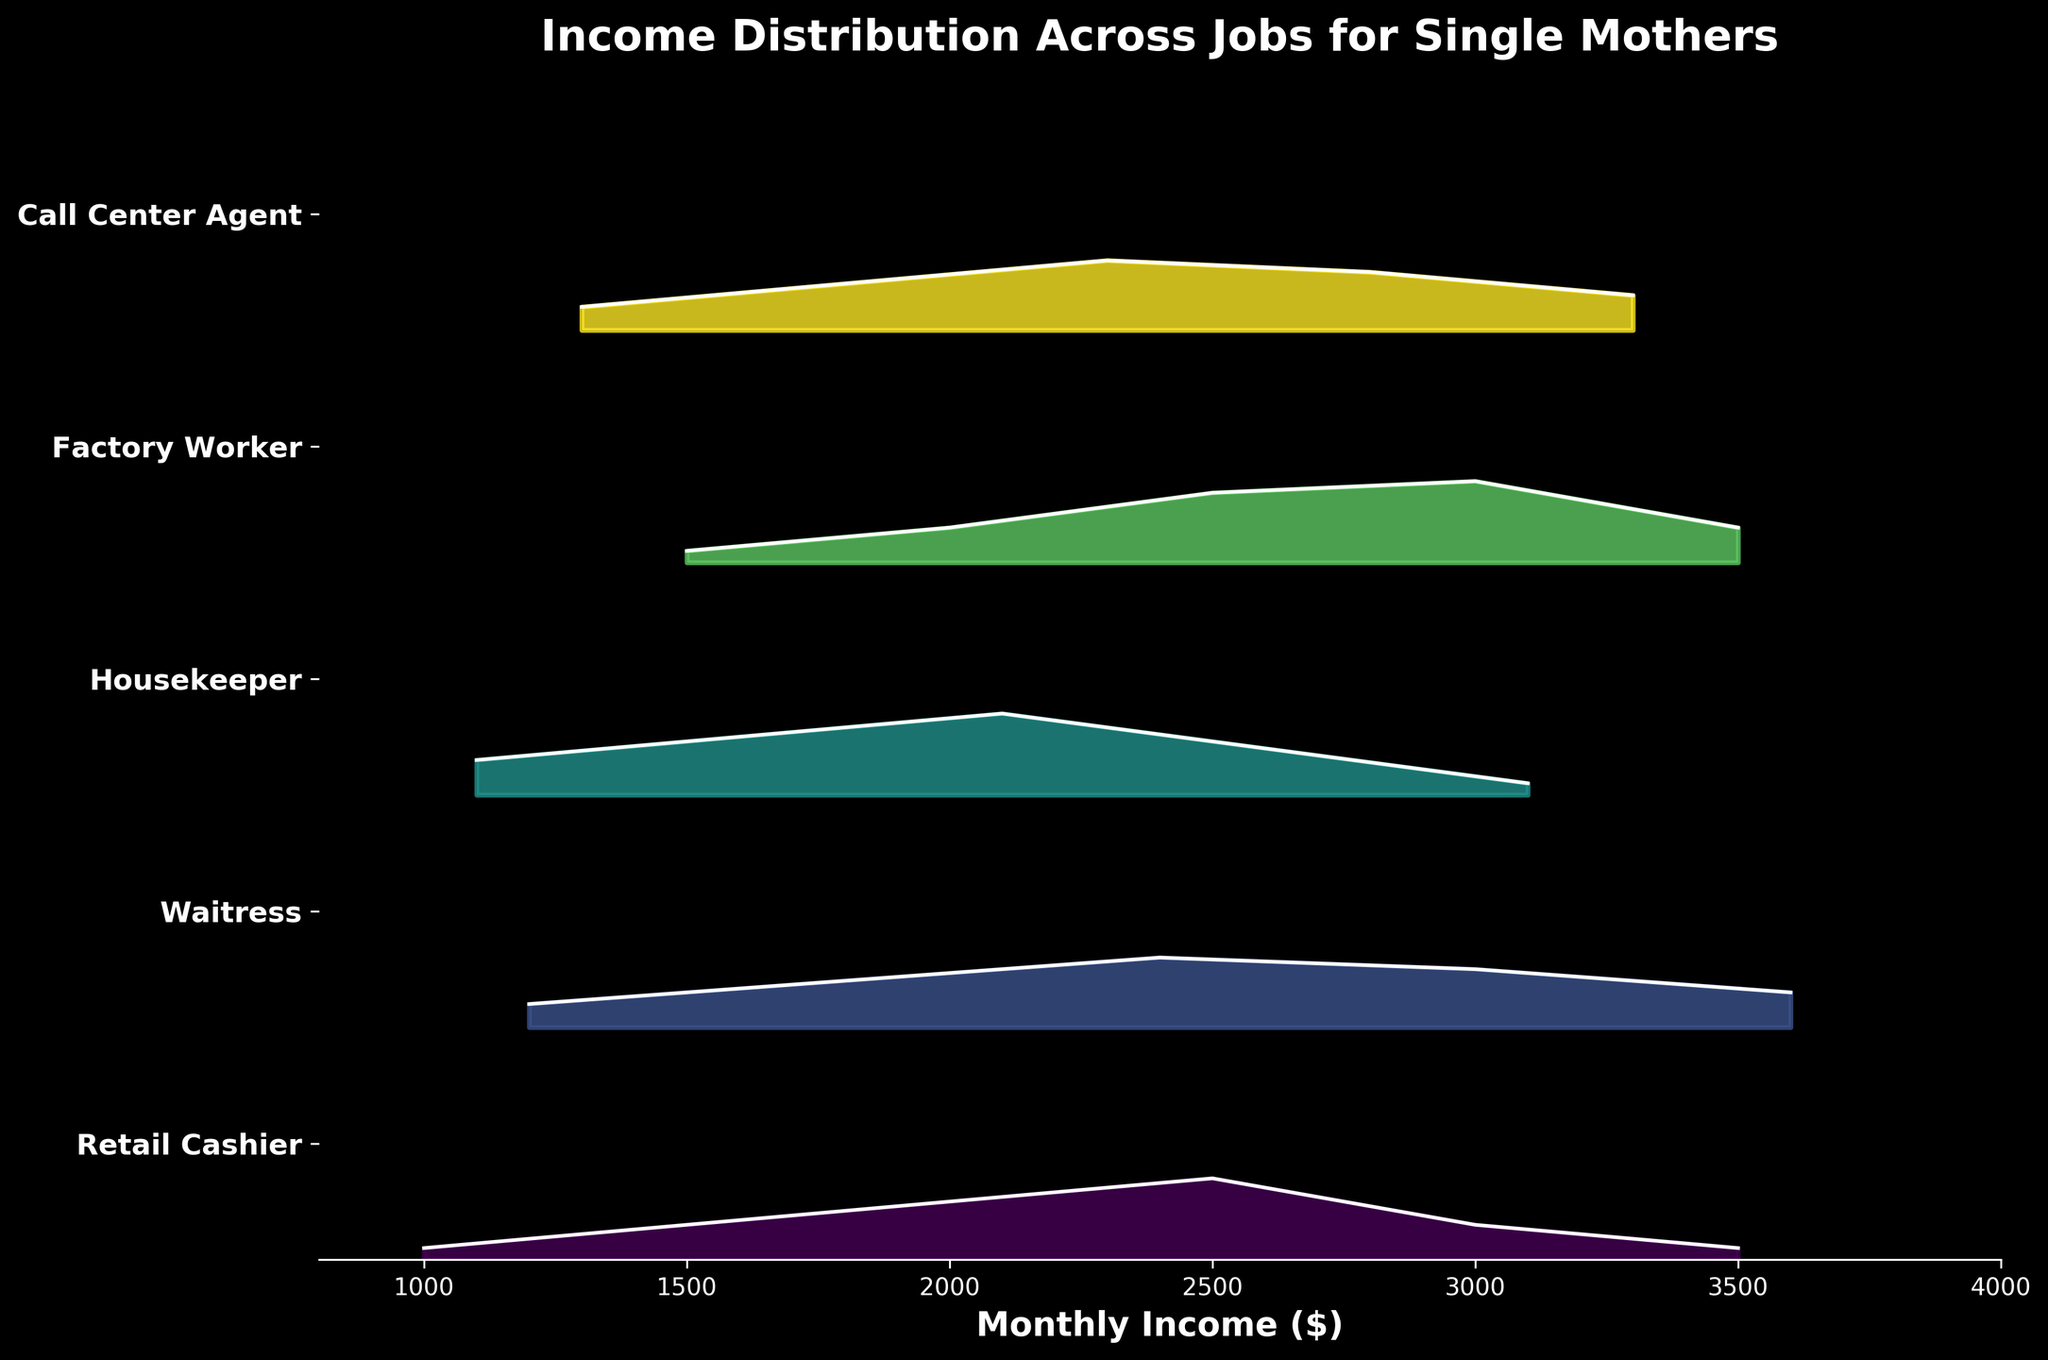Which job has the highest peak density in its monthly income distribution? The Ridgeline plot shows the peak density for each job's income distribution. By visually comparing the heights of the peaks, Housekeeper has the highest peak density at 0.35.
Answer: Housekeeper What is the median monthly income for a Retail Cashier? To find the median, we look for the middle value when incomes are ordered. For Retail Cashiers, incomes are 1000, 1500, 2000, 2500, 3000, and 3500. The average of the middle two values (2000 and 2500) is (2000+2500)/2 = 2250.
Answer: 2250 Which job has the widest range of income depicted in the plot? To determine this, we look at the spread of the incomes for each job. Retail Cashier ranges from 1000 to 3500, Waitress 1200 to 3600, Housekeeper 1100 to 3100, Factory Worker 1500 to 3500, Call Center Agent 1300 to 3300. Waitress has the widest range (1200 to 3600).
Answer: Waitress Among the jobs shown, which one has the lowest monthly income depicted, and what is that income? By observing the income values on the x-axis, the lowest income depicted is for a Retail Cashier, which is $1000.
Answer: Retail Cashier ($1000) Compare the peak densities of Waitress and Call Center Agent - which is higher? Comparing visually, the peak density for Waitress is 0.30 while for Call Center Agent it is also 0.30. Both jobs have the same highest peak density.
Answer: Both are equal Does any job have a peak density exactly at $3000? If so, which job(s)? By examining the peak densities aligned with the $3000 mark, we see that Factory Worker and Waitress both have peaks at $3000.
Answer: Factory Worker and Waitress Which job shows the most consistent distribution of income without extreme peaks or valleys? By examining the distribution shapes, Call Center Agent shows a relatively smooth distribution without sharp peaks or valleys compared to other jobs.
Answer: Call Center Agent Between Housekeepers and Factory Workers, which job tends to have higher incomes, on average? Housekeepers have incomes ranging from 1100 to 3100, and Factory Workers from 1500 to 3500. Given these ranges, Factory Workers tend to have higher incomes on average.
Answer: Factory Workers 